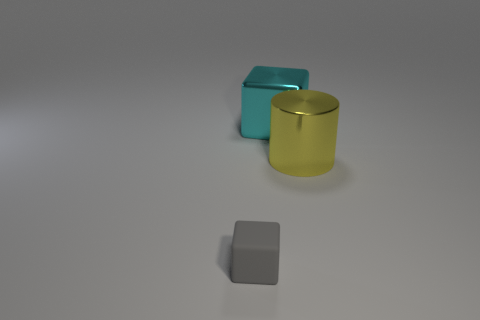Add 1 cyan shiny cubes. How many objects exist? 4 Subtract all cylinders. How many objects are left? 2 Subtract 0 purple cylinders. How many objects are left? 3 Subtract all big cylinders. Subtract all tiny gray blocks. How many objects are left? 1 Add 1 shiny cylinders. How many shiny cylinders are left? 2 Add 3 small gray matte things. How many small gray matte things exist? 4 